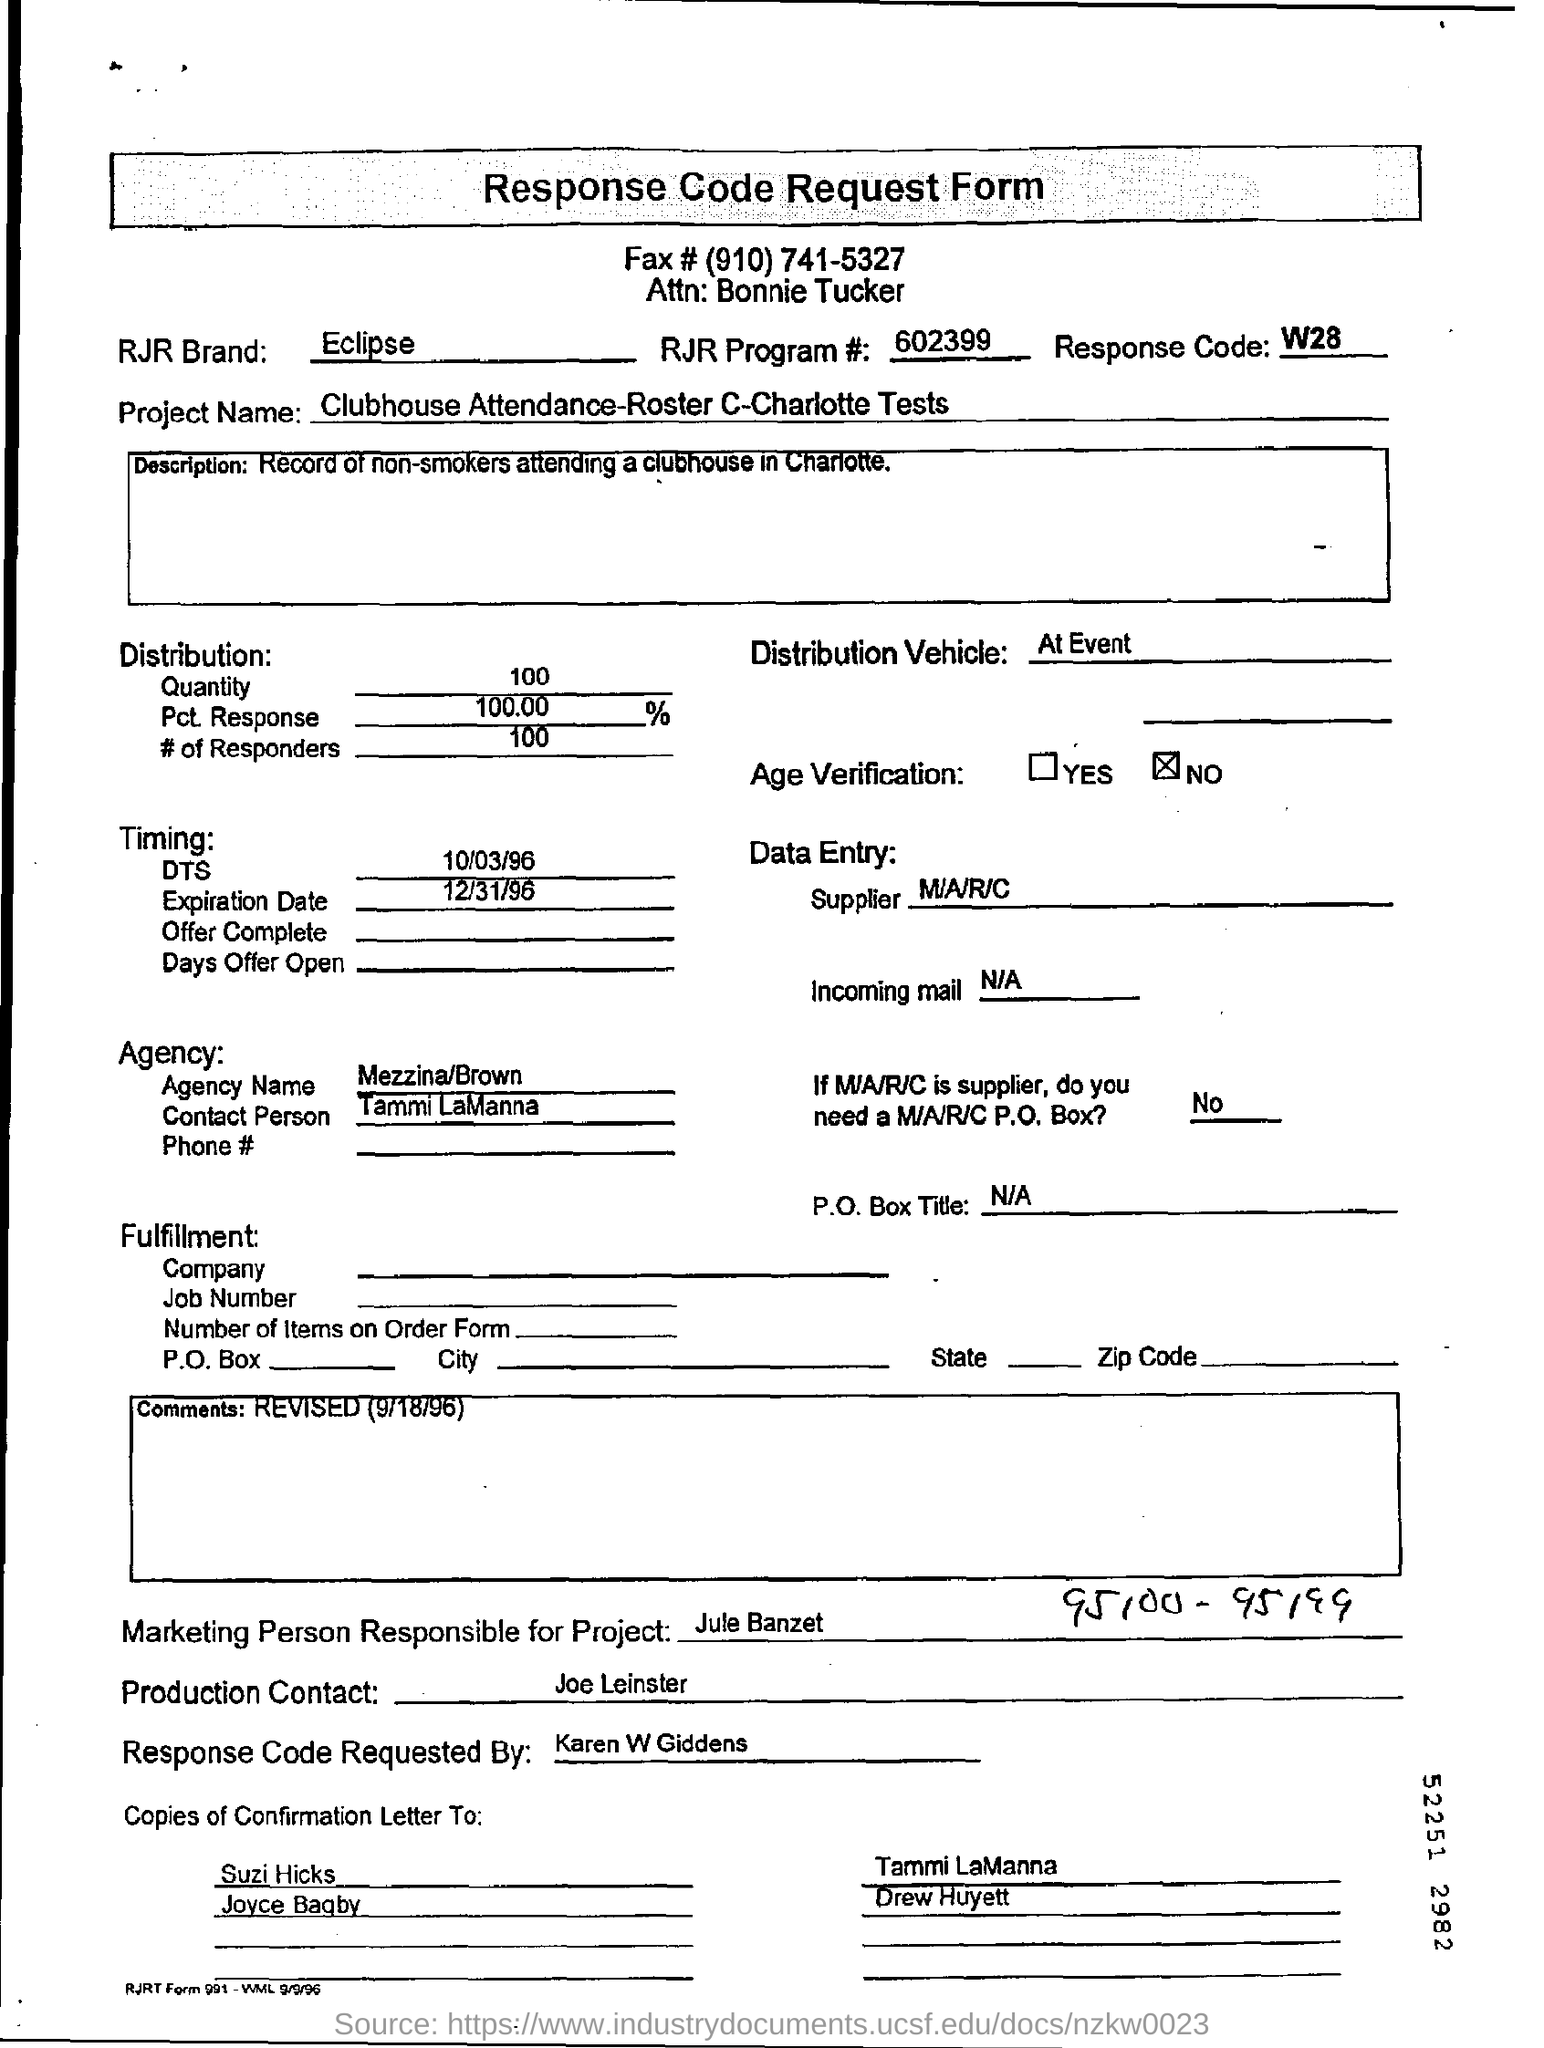What is the RJR Brand given in the form?
Your answer should be very brief. Eclipse. Who is the Attn to?
Keep it short and to the point. Bonnie Tucker. What is the DTS?
Offer a terse response. 10/03/96. What is the expiration date?
Keep it short and to the point. 12/31/96. Who is the supplier?
Provide a short and direct response. M/A/R/C. Who is the marketing person responsible for the project?
Provide a short and direct response. Jule Banzet. Who is the production contact?
Keep it short and to the point. Joe Leinster. The response code was requested by whom?
Give a very brief answer. Karen W Giddens. What is the response code?
Offer a very short reply. W28. What is the RJR Program #?
Your response must be concise. 602399. 